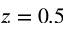<formula> <loc_0><loc_0><loc_500><loc_500>z = 0 . 5</formula> 